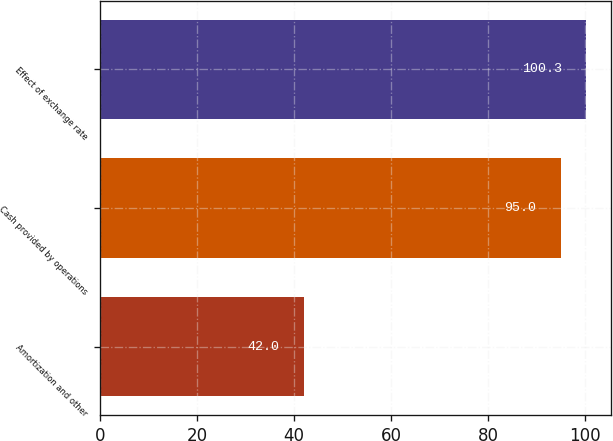Convert chart. <chart><loc_0><loc_0><loc_500><loc_500><bar_chart><fcel>Amortization and other<fcel>Cash provided by operations<fcel>Effect of exchange rate<nl><fcel>42<fcel>95<fcel>100.3<nl></chart> 